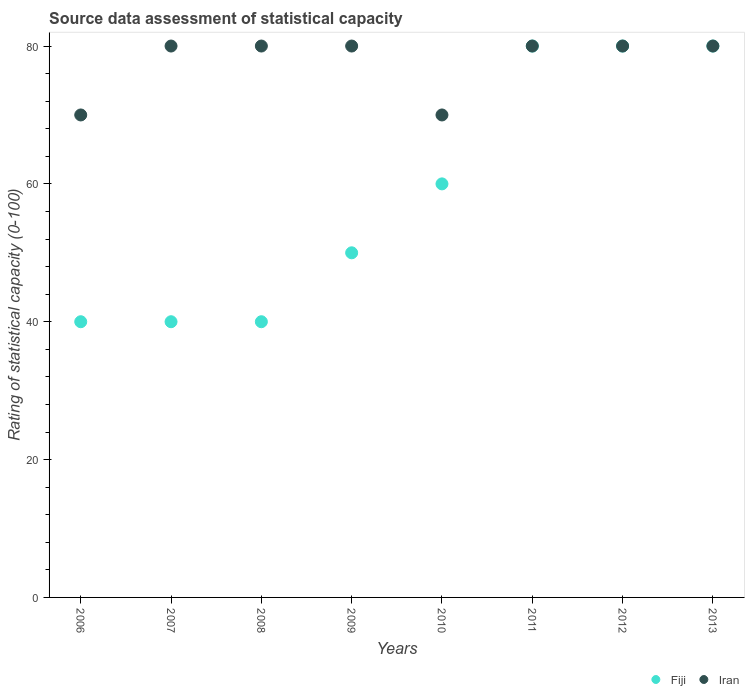What is the rating of statistical capacity in Iran in 2009?
Offer a very short reply. 80. Across all years, what is the minimum rating of statistical capacity in Fiji?
Your response must be concise. 40. In which year was the rating of statistical capacity in Iran maximum?
Your response must be concise. 2007. In which year was the rating of statistical capacity in Fiji minimum?
Give a very brief answer. 2006. What is the total rating of statistical capacity in Fiji in the graph?
Your answer should be compact. 470. What is the difference between the rating of statistical capacity in Iran in 2010 and that in 2011?
Provide a short and direct response. -10. What is the difference between the rating of statistical capacity in Iran in 2006 and the rating of statistical capacity in Fiji in 2013?
Your response must be concise. -10. What is the average rating of statistical capacity in Iran per year?
Offer a very short reply. 77.5. In the year 2012, what is the difference between the rating of statistical capacity in Iran and rating of statistical capacity in Fiji?
Ensure brevity in your answer.  0. What is the ratio of the rating of statistical capacity in Fiji in 2011 to that in 2013?
Provide a short and direct response. 1. Is the rating of statistical capacity in Fiji in 2007 less than that in 2011?
Your answer should be compact. Yes. Is the difference between the rating of statistical capacity in Iran in 2009 and 2010 greater than the difference between the rating of statistical capacity in Fiji in 2009 and 2010?
Your answer should be very brief. Yes. What is the difference between the highest and the second highest rating of statistical capacity in Fiji?
Your answer should be compact. 0. What is the difference between the highest and the lowest rating of statistical capacity in Iran?
Provide a succinct answer. 10. Is the rating of statistical capacity in Fiji strictly greater than the rating of statistical capacity in Iran over the years?
Ensure brevity in your answer.  No. Is the rating of statistical capacity in Iran strictly less than the rating of statistical capacity in Fiji over the years?
Offer a very short reply. No. How many years are there in the graph?
Offer a very short reply. 8. Are the values on the major ticks of Y-axis written in scientific E-notation?
Offer a very short reply. No. Does the graph contain grids?
Keep it short and to the point. No. What is the title of the graph?
Provide a succinct answer. Source data assessment of statistical capacity. What is the label or title of the X-axis?
Offer a terse response. Years. What is the label or title of the Y-axis?
Ensure brevity in your answer.  Rating of statistical capacity (0-100). What is the Rating of statistical capacity (0-100) of Fiji in 2006?
Provide a short and direct response. 40. What is the Rating of statistical capacity (0-100) of Iran in 2006?
Offer a terse response. 70. What is the Rating of statistical capacity (0-100) of Iran in 2007?
Provide a succinct answer. 80. What is the Rating of statistical capacity (0-100) of Fiji in 2008?
Your response must be concise. 40. What is the Rating of statistical capacity (0-100) of Fiji in 2009?
Offer a terse response. 50. What is the Rating of statistical capacity (0-100) in Fiji in 2010?
Provide a short and direct response. 60. What is the Rating of statistical capacity (0-100) in Fiji in 2012?
Ensure brevity in your answer.  80. What is the Rating of statistical capacity (0-100) in Iran in 2013?
Offer a terse response. 80. Across all years, what is the maximum Rating of statistical capacity (0-100) in Iran?
Give a very brief answer. 80. What is the total Rating of statistical capacity (0-100) of Fiji in the graph?
Provide a short and direct response. 470. What is the total Rating of statistical capacity (0-100) of Iran in the graph?
Give a very brief answer. 620. What is the difference between the Rating of statistical capacity (0-100) in Fiji in 2006 and that in 2007?
Give a very brief answer. 0. What is the difference between the Rating of statistical capacity (0-100) of Fiji in 2006 and that in 2009?
Make the answer very short. -10. What is the difference between the Rating of statistical capacity (0-100) in Fiji in 2006 and that in 2010?
Make the answer very short. -20. What is the difference between the Rating of statistical capacity (0-100) in Iran in 2006 and that in 2010?
Ensure brevity in your answer.  0. What is the difference between the Rating of statistical capacity (0-100) in Iran in 2006 and that in 2011?
Your response must be concise. -10. What is the difference between the Rating of statistical capacity (0-100) of Iran in 2006 and that in 2012?
Ensure brevity in your answer.  -10. What is the difference between the Rating of statistical capacity (0-100) in Fiji in 2006 and that in 2013?
Give a very brief answer. -40. What is the difference between the Rating of statistical capacity (0-100) in Iran in 2006 and that in 2013?
Your answer should be compact. -10. What is the difference between the Rating of statistical capacity (0-100) of Iran in 2007 and that in 2008?
Keep it short and to the point. 0. What is the difference between the Rating of statistical capacity (0-100) of Fiji in 2007 and that in 2009?
Offer a terse response. -10. What is the difference between the Rating of statistical capacity (0-100) of Iran in 2007 and that in 2009?
Keep it short and to the point. 0. What is the difference between the Rating of statistical capacity (0-100) of Iran in 2007 and that in 2010?
Offer a terse response. 10. What is the difference between the Rating of statistical capacity (0-100) in Fiji in 2007 and that in 2011?
Your answer should be compact. -40. What is the difference between the Rating of statistical capacity (0-100) in Fiji in 2007 and that in 2012?
Ensure brevity in your answer.  -40. What is the difference between the Rating of statistical capacity (0-100) in Fiji in 2007 and that in 2013?
Give a very brief answer. -40. What is the difference between the Rating of statistical capacity (0-100) in Iran in 2007 and that in 2013?
Provide a short and direct response. 0. What is the difference between the Rating of statistical capacity (0-100) of Iran in 2008 and that in 2009?
Offer a very short reply. 0. What is the difference between the Rating of statistical capacity (0-100) of Iran in 2008 and that in 2010?
Give a very brief answer. 10. What is the difference between the Rating of statistical capacity (0-100) in Fiji in 2008 and that in 2011?
Offer a very short reply. -40. What is the difference between the Rating of statistical capacity (0-100) of Fiji in 2008 and that in 2012?
Make the answer very short. -40. What is the difference between the Rating of statistical capacity (0-100) in Iran in 2008 and that in 2012?
Keep it short and to the point. 0. What is the difference between the Rating of statistical capacity (0-100) in Fiji in 2008 and that in 2013?
Make the answer very short. -40. What is the difference between the Rating of statistical capacity (0-100) of Fiji in 2009 and that in 2010?
Keep it short and to the point. -10. What is the difference between the Rating of statistical capacity (0-100) in Fiji in 2009 and that in 2011?
Make the answer very short. -30. What is the difference between the Rating of statistical capacity (0-100) in Iran in 2009 and that in 2011?
Offer a very short reply. 0. What is the difference between the Rating of statistical capacity (0-100) of Iran in 2009 and that in 2013?
Your answer should be compact. 0. What is the difference between the Rating of statistical capacity (0-100) of Iran in 2010 and that in 2011?
Offer a very short reply. -10. What is the difference between the Rating of statistical capacity (0-100) in Fiji in 2010 and that in 2012?
Offer a very short reply. -20. What is the difference between the Rating of statistical capacity (0-100) of Iran in 2010 and that in 2012?
Provide a succinct answer. -10. What is the difference between the Rating of statistical capacity (0-100) in Fiji in 2010 and that in 2013?
Make the answer very short. -20. What is the difference between the Rating of statistical capacity (0-100) of Iran in 2011 and that in 2012?
Give a very brief answer. 0. What is the difference between the Rating of statistical capacity (0-100) in Fiji in 2011 and that in 2013?
Ensure brevity in your answer.  0. What is the difference between the Rating of statistical capacity (0-100) of Fiji in 2012 and that in 2013?
Offer a very short reply. 0. What is the difference between the Rating of statistical capacity (0-100) in Fiji in 2006 and the Rating of statistical capacity (0-100) in Iran in 2008?
Provide a succinct answer. -40. What is the difference between the Rating of statistical capacity (0-100) in Fiji in 2006 and the Rating of statistical capacity (0-100) in Iran in 2009?
Provide a short and direct response. -40. What is the difference between the Rating of statistical capacity (0-100) in Fiji in 2006 and the Rating of statistical capacity (0-100) in Iran in 2010?
Ensure brevity in your answer.  -30. What is the difference between the Rating of statistical capacity (0-100) in Fiji in 2006 and the Rating of statistical capacity (0-100) in Iran in 2011?
Make the answer very short. -40. What is the difference between the Rating of statistical capacity (0-100) of Fiji in 2006 and the Rating of statistical capacity (0-100) of Iran in 2012?
Your answer should be compact. -40. What is the difference between the Rating of statistical capacity (0-100) in Fiji in 2006 and the Rating of statistical capacity (0-100) in Iran in 2013?
Offer a very short reply. -40. What is the difference between the Rating of statistical capacity (0-100) of Fiji in 2007 and the Rating of statistical capacity (0-100) of Iran in 2009?
Offer a terse response. -40. What is the difference between the Rating of statistical capacity (0-100) of Fiji in 2007 and the Rating of statistical capacity (0-100) of Iran in 2010?
Offer a very short reply. -30. What is the difference between the Rating of statistical capacity (0-100) of Fiji in 2007 and the Rating of statistical capacity (0-100) of Iran in 2011?
Offer a very short reply. -40. What is the difference between the Rating of statistical capacity (0-100) in Fiji in 2007 and the Rating of statistical capacity (0-100) in Iran in 2013?
Offer a very short reply. -40. What is the difference between the Rating of statistical capacity (0-100) of Fiji in 2008 and the Rating of statistical capacity (0-100) of Iran in 2009?
Your response must be concise. -40. What is the difference between the Rating of statistical capacity (0-100) of Fiji in 2008 and the Rating of statistical capacity (0-100) of Iran in 2010?
Keep it short and to the point. -30. What is the difference between the Rating of statistical capacity (0-100) of Fiji in 2008 and the Rating of statistical capacity (0-100) of Iran in 2011?
Offer a very short reply. -40. What is the difference between the Rating of statistical capacity (0-100) of Fiji in 2008 and the Rating of statistical capacity (0-100) of Iran in 2012?
Your answer should be compact. -40. What is the difference between the Rating of statistical capacity (0-100) of Fiji in 2008 and the Rating of statistical capacity (0-100) of Iran in 2013?
Offer a very short reply. -40. What is the difference between the Rating of statistical capacity (0-100) of Fiji in 2009 and the Rating of statistical capacity (0-100) of Iran in 2011?
Give a very brief answer. -30. What is the difference between the Rating of statistical capacity (0-100) of Fiji in 2010 and the Rating of statistical capacity (0-100) of Iran in 2011?
Give a very brief answer. -20. What is the difference between the Rating of statistical capacity (0-100) in Fiji in 2010 and the Rating of statistical capacity (0-100) in Iran in 2012?
Offer a terse response. -20. What is the difference between the Rating of statistical capacity (0-100) of Fiji in 2012 and the Rating of statistical capacity (0-100) of Iran in 2013?
Give a very brief answer. 0. What is the average Rating of statistical capacity (0-100) of Fiji per year?
Give a very brief answer. 58.75. What is the average Rating of statistical capacity (0-100) of Iran per year?
Offer a very short reply. 77.5. In the year 2007, what is the difference between the Rating of statistical capacity (0-100) in Fiji and Rating of statistical capacity (0-100) in Iran?
Provide a short and direct response. -40. In the year 2008, what is the difference between the Rating of statistical capacity (0-100) of Fiji and Rating of statistical capacity (0-100) of Iran?
Give a very brief answer. -40. In the year 2012, what is the difference between the Rating of statistical capacity (0-100) in Fiji and Rating of statistical capacity (0-100) in Iran?
Offer a very short reply. 0. What is the ratio of the Rating of statistical capacity (0-100) in Fiji in 2006 to that in 2008?
Offer a very short reply. 1. What is the ratio of the Rating of statistical capacity (0-100) of Iran in 2006 to that in 2008?
Offer a very short reply. 0.88. What is the ratio of the Rating of statistical capacity (0-100) in Fiji in 2006 to that in 2009?
Provide a succinct answer. 0.8. What is the ratio of the Rating of statistical capacity (0-100) in Iran in 2006 to that in 2009?
Provide a short and direct response. 0.88. What is the ratio of the Rating of statistical capacity (0-100) in Fiji in 2006 to that in 2010?
Your answer should be compact. 0.67. What is the ratio of the Rating of statistical capacity (0-100) in Fiji in 2006 to that in 2012?
Your answer should be compact. 0.5. What is the ratio of the Rating of statistical capacity (0-100) of Fiji in 2006 to that in 2013?
Give a very brief answer. 0.5. What is the ratio of the Rating of statistical capacity (0-100) in Fiji in 2007 to that in 2009?
Your answer should be compact. 0.8. What is the ratio of the Rating of statistical capacity (0-100) of Iran in 2007 to that in 2009?
Your answer should be very brief. 1. What is the ratio of the Rating of statistical capacity (0-100) of Fiji in 2007 to that in 2010?
Offer a very short reply. 0.67. What is the ratio of the Rating of statistical capacity (0-100) in Iran in 2007 to that in 2011?
Offer a terse response. 1. What is the ratio of the Rating of statistical capacity (0-100) of Iran in 2007 to that in 2012?
Offer a terse response. 1. What is the ratio of the Rating of statistical capacity (0-100) of Fiji in 2007 to that in 2013?
Give a very brief answer. 0.5. What is the ratio of the Rating of statistical capacity (0-100) of Iran in 2007 to that in 2013?
Give a very brief answer. 1. What is the ratio of the Rating of statistical capacity (0-100) of Fiji in 2008 to that in 2009?
Give a very brief answer. 0.8. What is the ratio of the Rating of statistical capacity (0-100) of Fiji in 2008 to that in 2010?
Offer a terse response. 0.67. What is the ratio of the Rating of statistical capacity (0-100) of Iran in 2008 to that in 2010?
Your answer should be very brief. 1.14. What is the ratio of the Rating of statistical capacity (0-100) in Iran in 2008 to that in 2011?
Your answer should be compact. 1. What is the ratio of the Rating of statistical capacity (0-100) of Fiji in 2008 to that in 2013?
Provide a succinct answer. 0.5. What is the ratio of the Rating of statistical capacity (0-100) in Iran in 2008 to that in 2013?
Give a very brief answer. 1. What is the ratio of the Rating of statistical capacity (0-100) of Iran in 2009 to that in 2010?
Provide a succinct answer. 1.14. What is the ratio of the Rating of statistical capacity (0-100) of Iran in 2009 to that in 2011?
Make the answer very short. 1. What is the ratio of the Rating of statistical capacity (0-100) of Fiji in 2009 to that in 2012?
Make the answer very short. 0.62. What is the ratio of the Rating of statistical capacity (0-100) in Iran in 2009 to that in 2013?
Make the answer very short. 1. What is the ratio of the Rating of statistical capacity (0-100) of Fiji in 2010 to that in 2013?
Ensure brevity in your answer.  0.75. What is the ratio of the Rating of statistical capacity (0-100) in Iran in 2010 to that in 2013?
Offer a very short reply. 0.88. What is the ratio of the Rating of statistical capacity (0-100) of Fiji in 2011 to that in 2012?
Offer a terse response. 1. What is the ratio of the Rating of statistical capacity (0-100) of Iran in 2011 to that in 2013?
Give a very brief answer. 1. What is the ratio of the Rating of statistical capacity (0-100) in Iran in 2012 to that in 2013?
Your answer should be very brief. 1. What is the difference between the highest and the second highest Rating of statistical capacity (0-100) of Iran?
Your answer should be very brief. 0. 